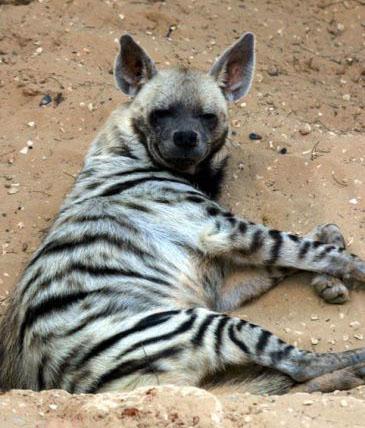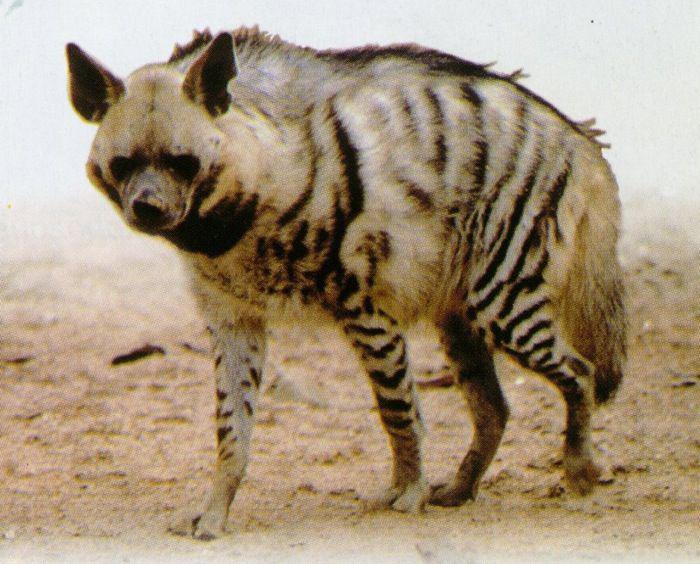The first image is the image on the left, the second image is the image on the right. Given the left and right images, does the statement "There is one striped animal in the image on the right." hold true? Answer yes or no. Yes. 